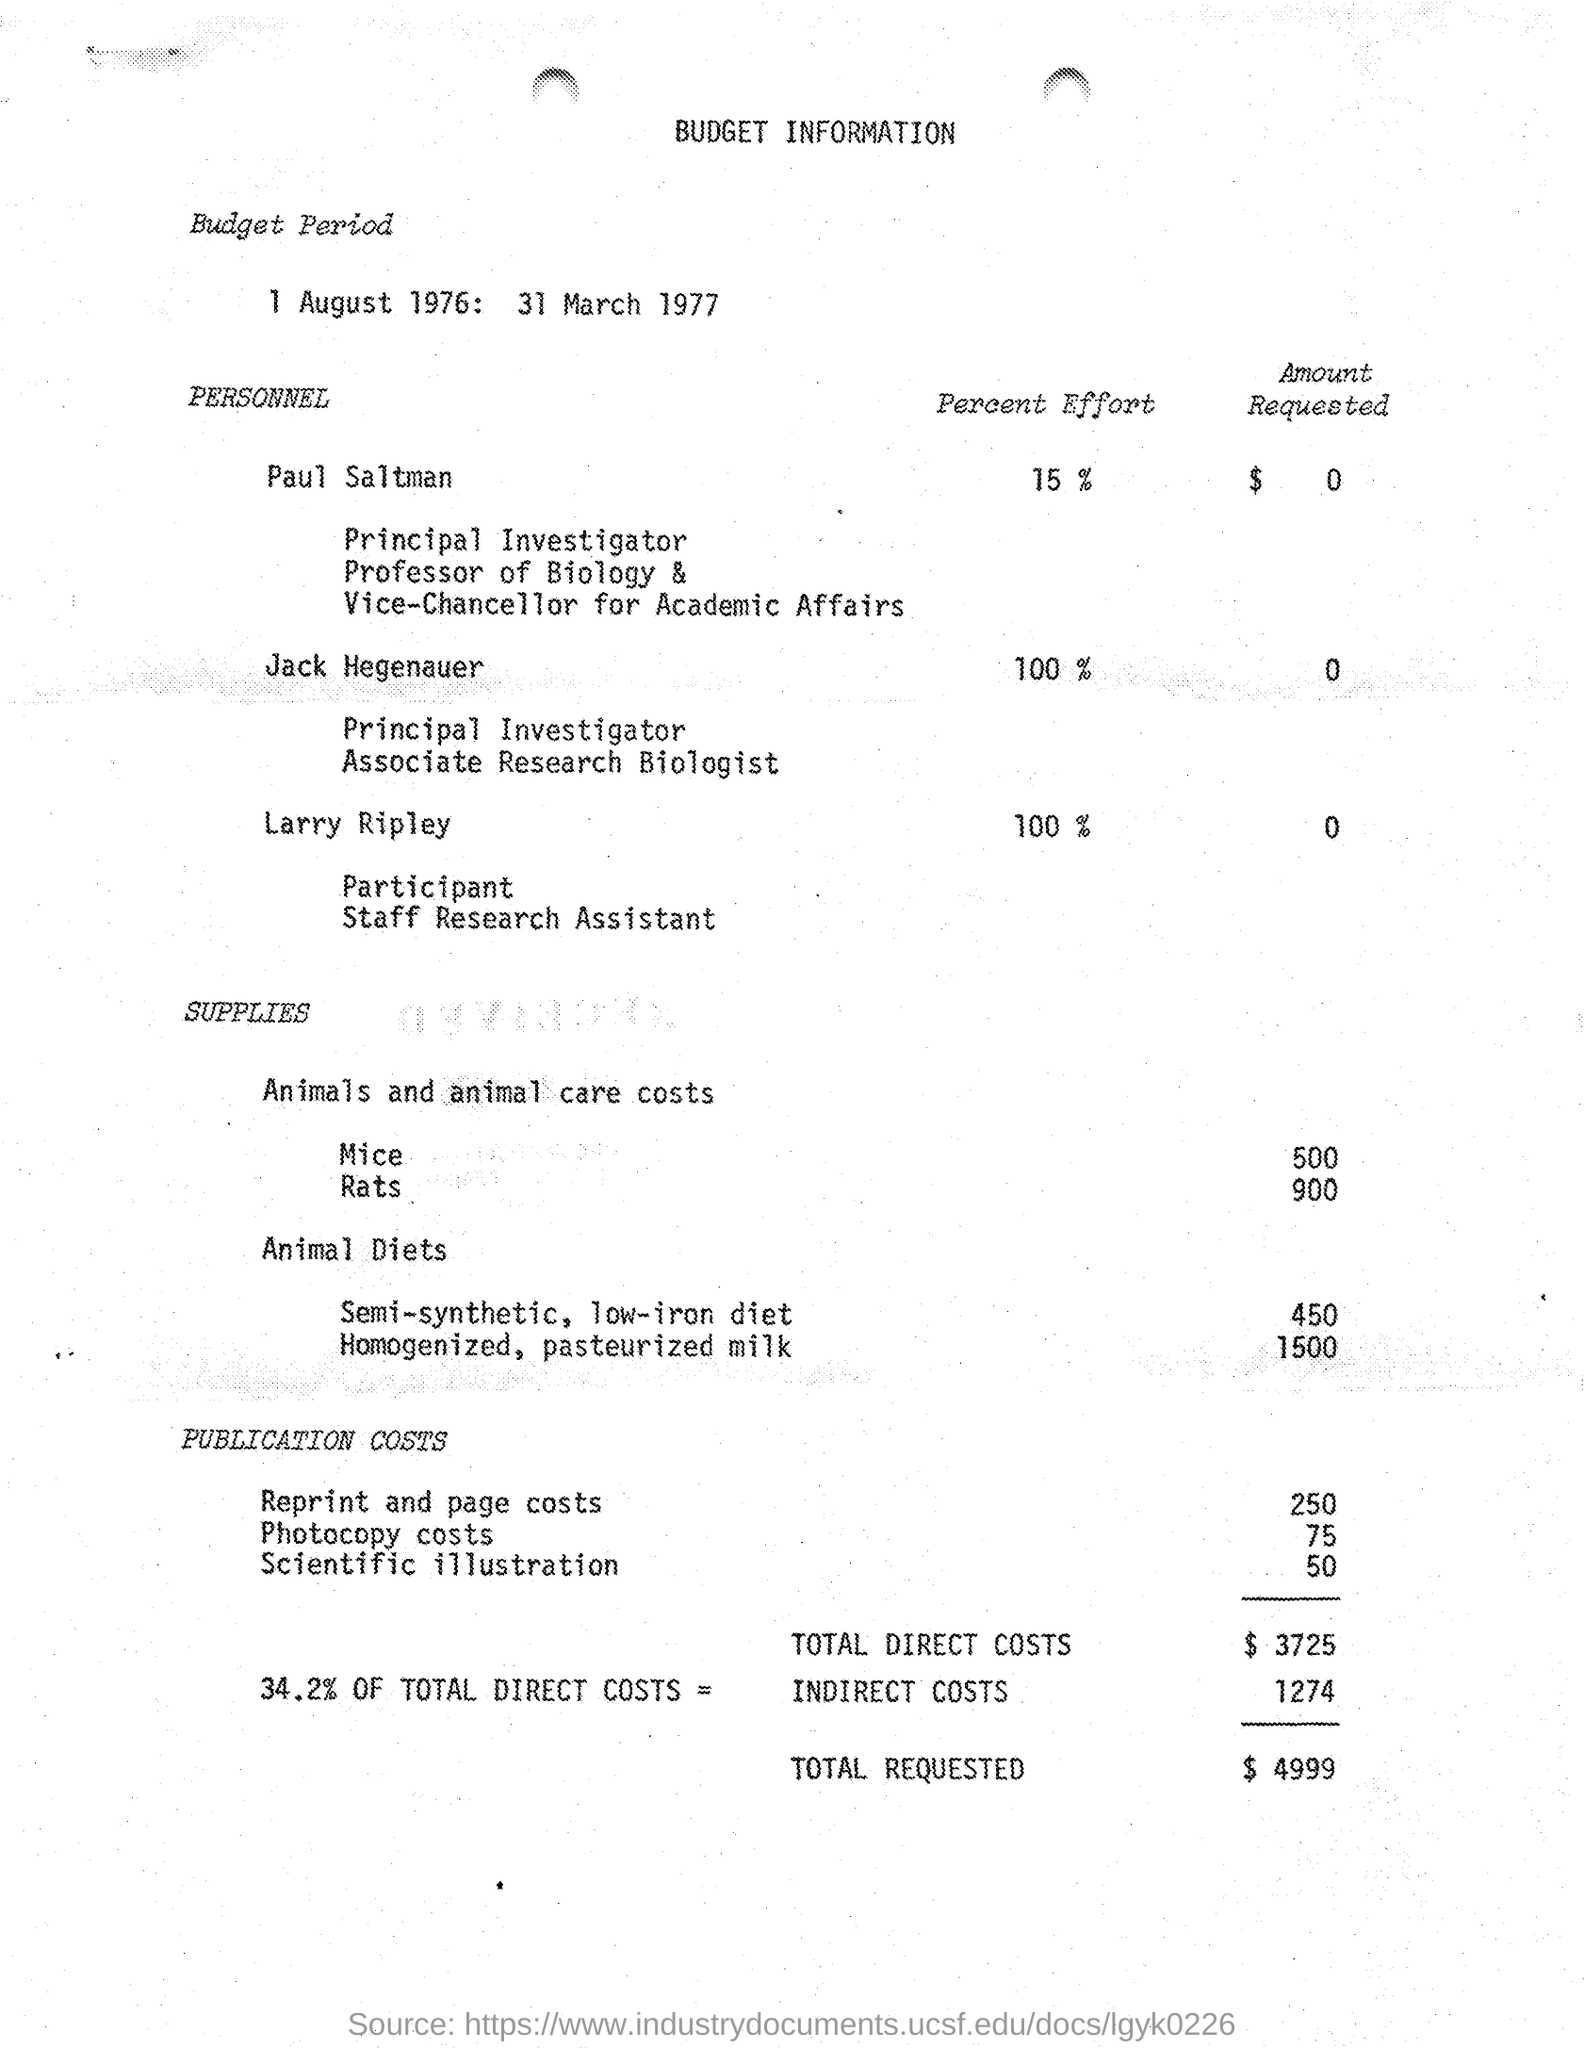Mention a couple of crucial points in this snapshot. The budget period referred to in the document is from 1 August 1976 to 31 March 1977. The estimated budget for reprint and page costs is $250. Jack Hegenauer is dedicating 100% of his effort to the project. The budget for scientific illustration, as per the document, is 50... The total direct costs budget is $3,725, as stated in the document. 